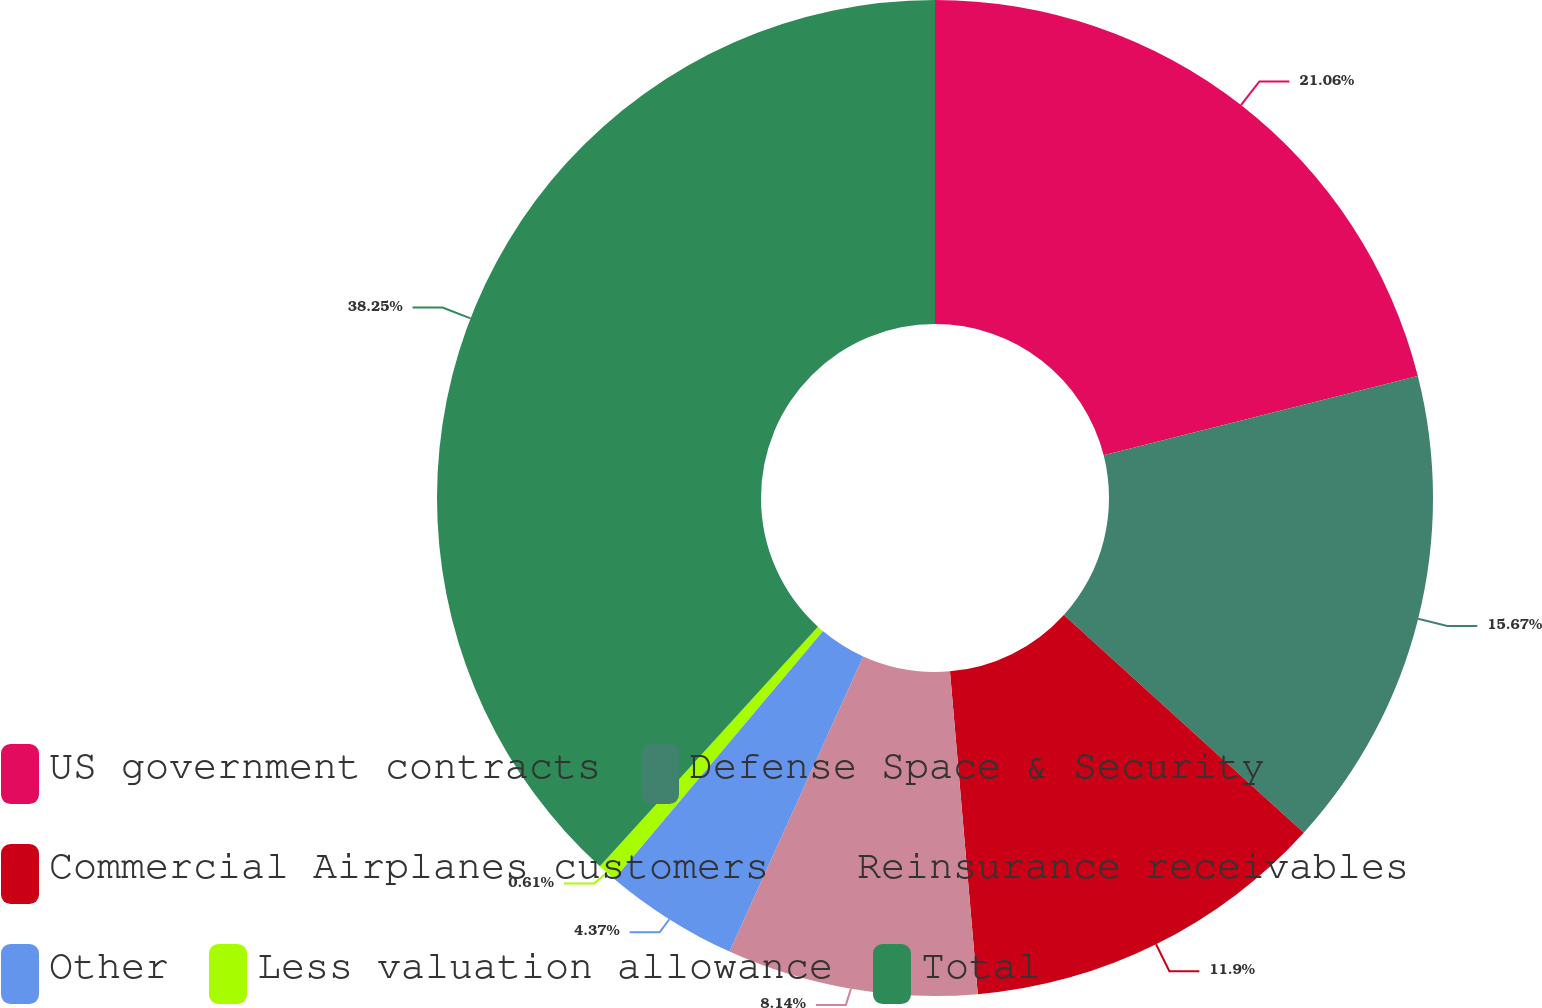Convert chart. <chart><loc_0><loc_0><loc_500><loc_500><pie_chart><fcel>US government contracts<fcel>Defense Space & Security<fcel>Commercial Airplanes customers<fcel>Reinsurance receivables<fcel>Other<fcel>Less valuation allowance<fcel>Total<nl><fcel>21.06%<fcel>15.67%<fcel>11.9%<fcel>8.14%<fcel>4.37%<fcel>0.61%<fcel>38.25%<nl></chart> 